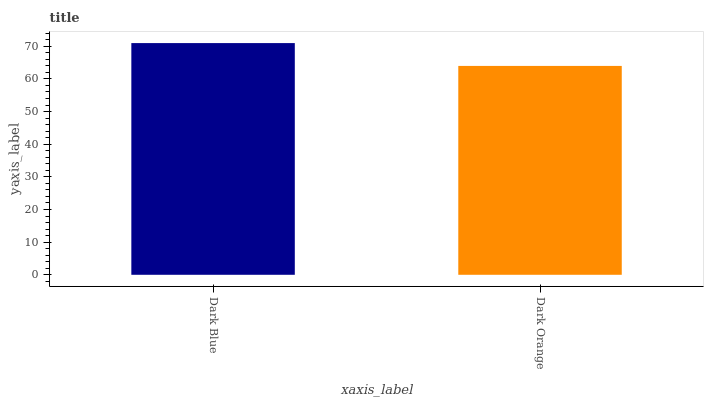Is Dark Orange the minimum?
Answer yes or no. Yes. Is Dark Blue the maximum?
Answer yes or no. Yes. Is Dark Orange the maximum?
Answer yes or no. No. Is Dark Blue greater than Dark Orange?
Answer yes or no. Yes. Is Dark Orange less than Dark Blue?
Answer yes or no. Yes. Is Dark Orange greater than Dark Blue?
Answer yes or no. No. Is Dark Blue less than Dark Orange?
Answer yes or no. No. Is Dark Blue the high median?
Answer yes or no. Yes. Is Dark Orange the low median?
Answer yes or no. Yes. Is Dark Orange the high median?
Answer yes or no. No. Is Dark Blue the low median?
Answer yes or no. No. 